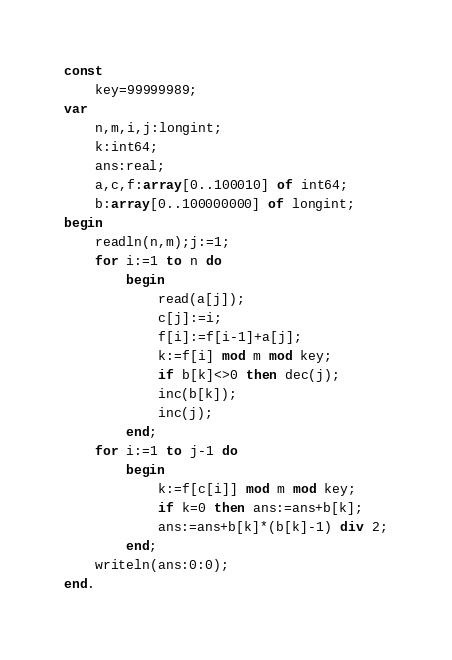Convert code to text. <code><loc_0><loc_0><loc_500><loc_500><_Pascal_>const
    key=99999989;
var
    n,m,i,j:longint;
    k:int64;
    ans:real;
    a,c,f:array[0..100010] of int64;
    b:array[0..100000000] of longint;
begin
    readln(n,m);j:=1;
    for i:=1 to n do
        begin
            read(a[j]);
            c[j]:=i;
            f[i]:=f[i-1]+a[j];
            k:=f[i] mod m mod key;
            if b[k]<>0 then dec(j);
            inc(b[k]);
            inc(j);
        end;
    for i:=1 to j-1 do
        begin 
            k:=f[c[i]] mod m mod key;
            if k=0 then ans:=ans+b[k];
            ans:=ans+b[k]*(b[k]-1) div 2;
        end;
    writeln(ans:0:0);
end.</code> 